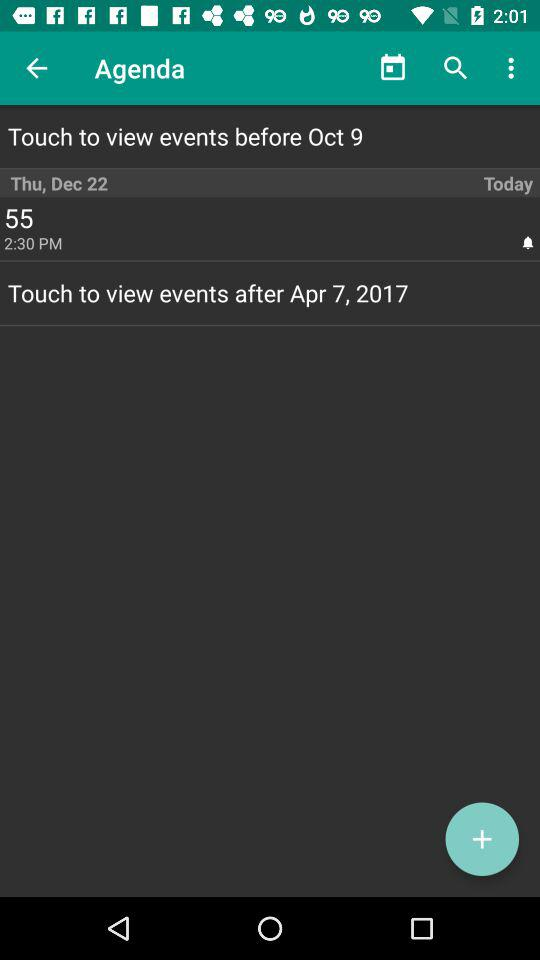At what time does event 55 end?
When the provided information is insufficient, respond with <no answer>. <no answer> 